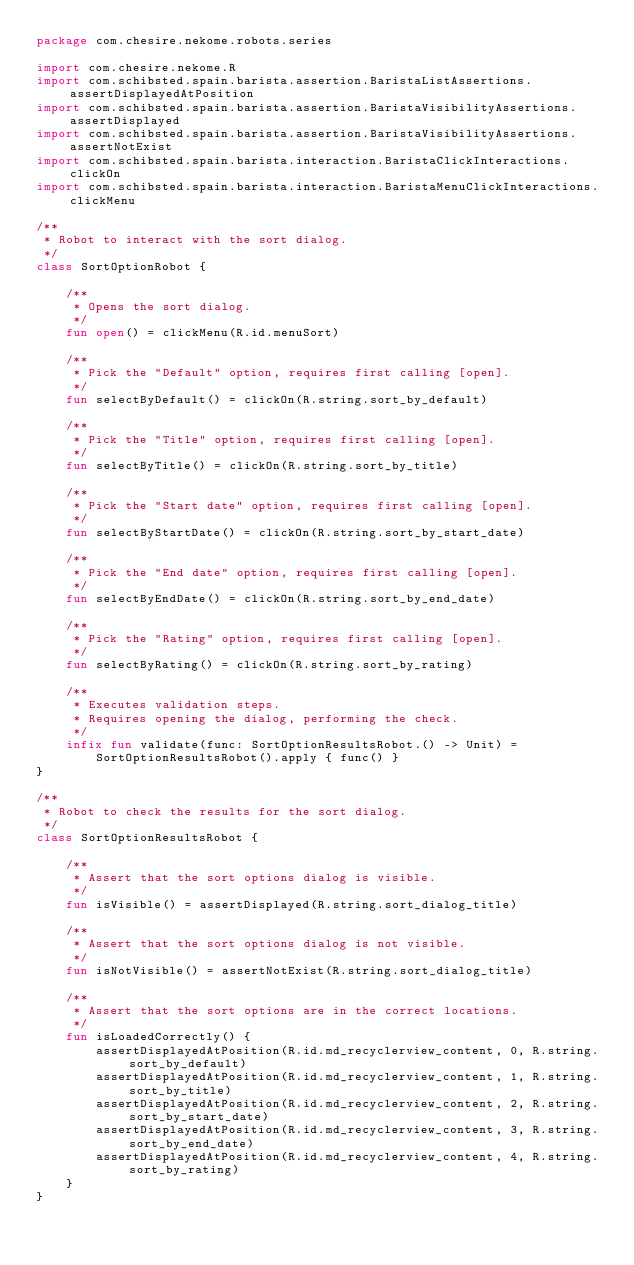Convert code to text. <code><loc_0><loc_0><loc_500><loc_500><_Kotlin_>package com.chesire.nekome.robots.series

import com.chesire.nekome.R
import com.schibsted.spain.barista.assertion.BaristaListAssertions.assertDisplayedAtPosition
import com.schibsted.spain.barista.assertion.BaristaVisibilityAssertions.assertDisplayed
import com.schibsted.spain.barista.assertion.BaristaVisibilityAssertions.assertNotExist
import com.schibsted.spain.barista.interaction.BaristaClickInteractions.clickOn
import com.schibsted.spain.barista.interaction.BaristaMenuClickInteractions.clickMenu

/**
 * Robot to interact with the sort dialog.
 */
class SortOptionRobot {

    /**
     * Opens the sort dialog.
     */
    fun open() = clickMenu(R.id.menuSort)

    /**
     * Pick the "Default" option, requires first calling [open].
     */
    fun selectByDefault() = clickOn(R.string.sort_by_default)

    /**
     * Pick the "Title" option, requires first calling [open].
     */
    fun selectByTitle() = clickOn(R.string.sort_by_title)

    /**
     * Pick the "Start date" option, requires first calling [open].
     */
    fun selectByStartDate() = clickOn(R.string.sort_by_start_date)

    /**
     * Pick the "End date" option, requires first calling [open].
     */
    fun selectByEndDate() = clickOn(R.string.sort_by_end_date)

    /**
     * Pick the "Rating" option, requires first calling [open].
     */
    fun selectByRating() = clickOn(R.string.sort_by_rating)

    /**
     * Executes validation steps.
     * Requires opening the dialog, performing the check.
     */
    infix fun validate(func: SortOptionResultsRobot.() -> Unit) =
        SortOptionResultsRobot().apply { func() }
}

/**
 * Robot to check the results for the sort dialog.
 */
class SortOptionResultsRobot {

    /**
     * Assert that the sort options dialog is visible.
     */
    fun isVisible() = assertDisplayed(R.string.sort_dialog_title)

    /**
     * Assert that the sort options dialog is not visible.
     */
    fun isNotVisible() = assertNotExist(R.string.sort_dialog_title)

    /**
     * Assert that the sort options are in the correct locations.
     */
    fun isLoadedCorrectly() {
        assertDisplayedAtPosition(R.id.md_recyclerview_content, 0, R.string.sort_by_default)
        assertDisplayedAtPosition(R.id.md_recyclerview_content, 1, R.string.sort_by_title)
        assertDisplayedAtPosition(R.id.md_recyclerview_content, 2, R.string.sort_by_start_date)
        assertDisplayedAtPosition(R.id.md_recyclerview_content, 3, R.string.sort_by_end_date)
        assertDisplayedAtPosition(R.id.md_recyclerview_content, 4, R.string.sort_by_rating)
    }
}
</code> 